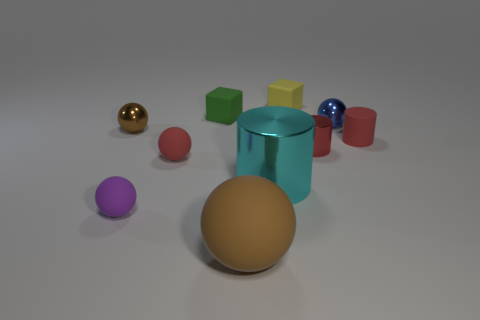Does the yellow rubber object have the same size as the red cylinder right of the small red shiny thing?
Keep it short and to the point. Yes. There is a object that is to the left of the red matte ball and on the right side of the brown metallic sphere; what is its color?
Provide a succinct answer. Purple. How many objects are either objects to the left of the large brown rubber ball or cubes on the right side of the large cyan metallic object?
Give a very brief answer. 5. There is a metal ball that is on the right side of the small rubber ball in front of the red thing to the left of the cyan shiny thing; what is its color?
Your answer should be compact. Blue. Is there a big yellow thing of the same shape as the small red shiny thing?
Ensure brevity in your answer.  No. What number of red objects are there?
Give a very brief answer. 3. There is a big shiny object; what shape is it?
Keep it short and to the point. Cylinder. How many other shiny objects are the same size as the yellow thing?
Provide a short and direct response. 3. Is the big brown rubber object the same shape as the tiny brown metal thing?
Give a very brief answer. Yes. What color is the tiny ball on the right side of the red cylinder that is to the left of the red matte cylinder?
Ensure brevity in your answer.  Blue. 